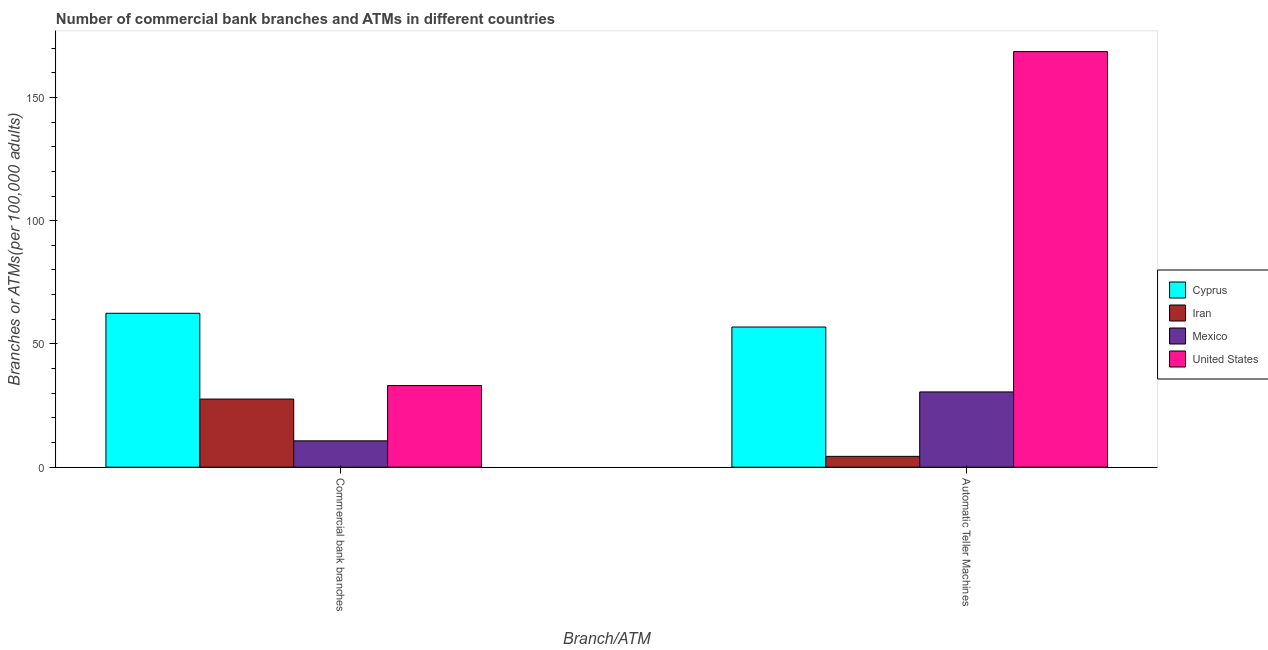How many different coloured bars are there?
Give a very brief answer. 4. Are the number of bars per tick equal to the number of legend labels?
Your response must be concise. Yes. Are the number of bars on each tick of the X-axis equal?
Your answer should be compact. Yes. How many bars are there on the 1st tick from the left?
Your answer should be compact. 4. What is the label of the 2nd group of bars from the left?
Keep it short and to the point. Automatic Teller Machines. What is the number of atms in Cyprus?
Keep it short and to the point. 56.87. Across all countries, what is the maximum number of commercal bank branches?
Your answer should be very brief. 62.44. Across all countries, what is the minimum number of commercal bank branches?
Your response must be concise. 10.7. In which country was the number of commercal bank branches maximum?
Offer a very short reply. Cyprus. What is the total number of commercal bank branches in the graph?
Your answer should be compact. 133.9. What is the difference between the number of commercal bank branches in Iran and that in United States?
Your response must be concise. -5.49. What is the difference between the number of commercal bank branches in United States and the number of atms in Mexico?
Provide a succinct answer. 2.59. What is the average number of commercal bank branches per country?
Provide a short and direct response. 33.47. What is the difference between the number of atms and number of commercal bank branches in United States?
Ensure brevity in your answer.  135.46. What is the ratio of the number of atms in United States to that in Mexico?
Provide a short and direct response. 5.52. What does the 2nd bar from the left in Commercial bank branches represents?
Make the answer very short. Iran. What does the 2nd bar from the right in Automatic Teller Machines represents?
Provide a short and direct response. Mexico. How many bars are there?
Offer a very short reply. 8. How many countries are there in the graph?
Your answer should be very brief. 4. What is the difference between two consecutive major ticks on the Y-axis?
Your answer should be very brief. 50. Does the graph contain any zero values?
Ensure brevity in your answer.  No. How many legend labels are there?
Your response must be concise. 4. What is the title of the graph?
Offer a very short reply. Number of commercial bank branches and ATMs in different countries. Does "Low income" appear as one of the legend labels in the graph?
Your answer should be very brief. No. What is the label or title of the X-axis?
Offer a very short reply. Branch/ATM. What is the label or title of the Y-axis?
Ensure brevity in your answer.  Branches or ATMs(per 100,0 adults). What is the Branches or ATMs(per 100,000 adults) of Cyprus in Commercial bank branches?
Keep it short and to the point. 62.44. What is the Branches or ATMs(per 100,000 adults) in Iran in Commercial bank branches?
Ensure brevity in your answer.  27.64. What is the Branches or ATMs(per 100,000 adults) of Mexico in Commercial bank branches?
Keep it short and to the point. 10.7. What is the Branches or ATMs(per 100,000 adults) of United States in Commercial bank branches?
Keep it short and to the point. 33.13. What is the Branches or ATMs(per 100,000 adults) of Cyprus in Automatic Teller Machines?
Your answer should be compact. 56.87. What is the Branches or ATMs(per 100,000 adults) of Iran in Automatic Teller Machines?
Make the answer very short. 4.4. What is the Branches or ATMs(per 100,000 adults) of Mexico in Automatic Teller Machines?
Your response must be concise. 30.54. What is the Branches or ATMs(per 100,000 adults) of United States in Automatic Teller Machines?
Make the answer very short. 168.59. Across all Branch/ATM, what is the maximum Branches or ATMs(per 100,000 adults) in Cyprus?
Provide a succinct answer. 62.44. Across all Branch/ATM, what is the maximum Branches or ATMs(per 100,000 adults) of Iran?
Offer a very short reply. 27.64. Across all Branch/ATM, what is the maximum Branches or ATMs(per 100,000 adults) in Mexico?
Make the answer very short. 30.54. Across all Branch/ATM, what is the maximum Branches or ATMs(per 100,000 adults) of United States?
Your answer should be very brief. 168.59. Across all Branch/ATM, what is the minimum Branches or ATMs(per 100,000 adults) of Cyprus?
Keep it short and to the point. 56.87. Across all Branch/ATM, what is the minimum Branches or ATMs(per 100,000 adults) in Iran?
Your answer should be compact. 4.4. Across all Branch/ATM, what is the minimum Branches or ATMs(per 100,000 adults) in Mexico?
Your response must be concise. 10.7. Across all Branch/ATM, what is the minimum Branches or ATMs(per 100,000 adults) in United States?
Your answer should be compact. 33.13. What is the total Branches or ATMs(per 100,000 adults) of Cyprus in the graph?
Offer a terse response. 119.3. What is the total Branches or ATMs(per 100,000 adults) of Iran in the graph?
Your response must be concise. 32.03. What is the total Branches or ATMs(per 100,000 adults) in Mexico in the graph?
Ensure brevity in your answer.  41.23. What is the total Branches or ATMs(per 100,000 adults) of United States in the graph?
Provide a short and direct response. 201.72. What is the difference between the Branches or ATMs(per 100,000 adults) of Cyprus in Commercial bank branches and that in Automatic Teller Machines?
Give a very brief answer. 5.57. What is the difference between the Branches or ATMs(per 100,000 adults) of Iran in Commercial bank branches and that in Automatic Teller Machines?
Provide a short and direct response. 23.24. What is the difference between the Branches or ATMs(per 100,000 adults) in Mexico in Commercial bank branches and that in Automatic Teller Machines?
Provide a succinct answer. -19.84. What is the difference between the Branches or ATMs(per 100,000 adults) of United States in Commercial bank branches and that in Automatic Teller Machines?
Your answer should be compact. -135.46. What is the difference between the Branches or ATMs(per 100,000 adults) of Cyprus in Commercial bank branches and the Branches or ATMs(per 100,000 adults) of Iran in Automatic Teller Machines?
Provide a short and direct response. 58.04. What is the difference between the Branches or ATMs(per 100,000 adults) of Cyprus in Commercial bank branches and the Branches or ATMs(per 100,000 adults) of Mexico in Automatic Teller Machines?
Offer a very short reply. 31.9. What is the difference between the Branches or ATMs(per 100,000 adults) of Cyprus in Commercial bank branches and the Branches or ATMs(per 100,000 adults) of United States in Automatic Teller Machines?
Provide a short and direct response. -106.16. What is the difference between the Branches or ATMs(per 100,000 adults) in Iran in Commercial bank branches and the Branches or ATMs(per 100,000 adults) in Mexico in Automatic Teller Machines?
Your answer should be compact. -2.9. What is the difference between the Branches or ATMs(per 100,000 adults) of Iran in Commercial bank branches and the Branches or ATMs(per 100,000 adults) of United States in Automatic Teller Machines?
Provide a short and direct response. -140.96. What is the difference between the Branches or ATMs(per 100,000 adults) in Mexico in Commercial bank branches and the Branches or ATMs(per 100,000 adults) in United States in Automatic Teller Machines?
Your response must be concise. -157.9. What is the average Branches or ATMs(per 100,000 adults) in Cyprus per Branch/ATM?
Offer a very short reply. 59.65. What is the average Branches or ATMs(per 100,000 adults) of Iran per Branch/ATM?
Your answer should be compact. 16.02. What is the average Branches or ATMs(per 100,000 adults) of Mexico per Branch/ATM?
Offer a very short reply. 20.62. What is the average Branches or ATMs(per 100,000 adults) in United States per Branch/ATM?
Your response must be concise. 100.86. What is the difference between the Branches or ATMs(per 100,000 adults) of Cyprus and Branches or ATMs(per 100,000 adults) of Iran in Commercial bank branches?
Give a very brief answer. 34.8. What is the difference between the Branches or ATMs(per 100,000 adults) in Cyprus and Branches or ATMs(per 100,000 adults) in Mexico in Commercial bank branches?
Make the answer very short. 51.74. What is the difference between the Branches or ATMs(per 100,000 adults) of Cyprus and Branches or ATMs(per 100,000 adults) of United States in Commercial bank branches?
Your response must be concise. 29.31. What is the difference between the Branches or ATMs(per 100,000 adults) of Iran and Branches or ATMs(per 100,000 adults) of Mexico in Commercial bank branches?
Give a very brief answer. 16.94. What is the difference between the Branches or ATMs(per 100,000 adults) in Iran and Branches or ATMs(per 100,000 adults) in United States in Commercial bank branches?
Make the answer very short. -5.49. What is the difference between the Branches or ATMs(per 100,000 adults) in Mexico and Branches or ATMs(per 100,000 adults) in United States in Commercial bank branches?
Provide a short and direct response. -22.43. What is the difference between the Branches or ATMs(per 100,000 adults) of Cyprus and Branches or ATMs(per 100,000 adults) of Iran in Automatic Teller Machines?
Your answer should be very brief. 52.47. What is the difference between the Branches or ATMs(per 100,000 adults) of Cyprus and Branches or ATMs(per 100,000 adults) of Mexico in Automatic Teller Machines?
Provide a short and direct response. 26.33. What is the difference between the Branches or ATMs(per 100,000 adults) in Cyprus and Branches or ATMs(per 100,000 adults) in United States in Automatic Teller Machines?
Provide a succinct answer. -111.72. What is the difference between the Branches or ATMs(per 100,000 adults) of Iran and Branches or ATMs(per 100,000 adults) of Mexico in Automatic Teller Machines?
Keep it short and to the point. -26.14. What is the difference between the Branches or ATMs(per 100,000 adults) of Iran and Branches or ATMs(per 100,000 adults) of United States in Automatic Teller Machines?
Make the answer very short. -164.19. What is the difference between the Branches or ATMs(per 100,000 adults) in Mexico and Branches or ATMs(per 100,000 adults) in United States in Automatic Teller Machines?
Your answer should be very brief. -138.06. What is the ratio of the Branches or ATMs(per 100,000 adults) in Cyprus in Commercial bank branches to that in Automatic Teller Machines?
Your response must be concise. 1.1. What is the ratio of the Branches or ATMs(per 100,000 adults) in Iran in Commercial bank branches to that in Automatic Teller Machines?
Provide a succinct answer. 6.28. What is the ratio of the Branches or ATMs(per 100,000 adults) in Mexico in Commercial bank branches to that in Automatic Teller Machines?
Provide a succinct answer. 0.35. What is the ratio of the Branches or ATMs(per 100,000 adults) of United States in Commercial bank branches to that in Automatic Teller Machines?
Offer a terse response. 0.2. What is the difference between the highest and the second highest Branches or ATMs(per 100,000 adults) of Cyprus?
Offer a very short reply. 5.57. What is the difference between the highest and the second highest Branches or ATMs(per 100,000 adults) of Iran?
Your response must be concise. 23.24. What is the difference between the highest and the second highest Branches or ATMs(per 100,000 adults) of Mexico?
Give a very brief answer. 19.84. What is the difference between the highest and the second highest Branches or ATMs(per 100,000 adults) in United States?
Offer a terse response. 135.46. What is the difference between the highest and the lowest Branches or ATMs(per 100,000 adults) of Cyprus?
Provide a succinct answer. 5.57. What is the difference between the highest and the lowest Branches or ATMs(per 100,000 adults) of Iran?
Provide a succinct answer. 23.24. What is the difference between the highest and the lowest Branches or ATMs(per 100,000 adults) in Mexico?
Ensure brevity in your answer.  19.84. What is the difference between the highest and the lowest Branches or ATMs(per 100,000 adults) of United States?
Ensure brevity in your answer.  135.46. 